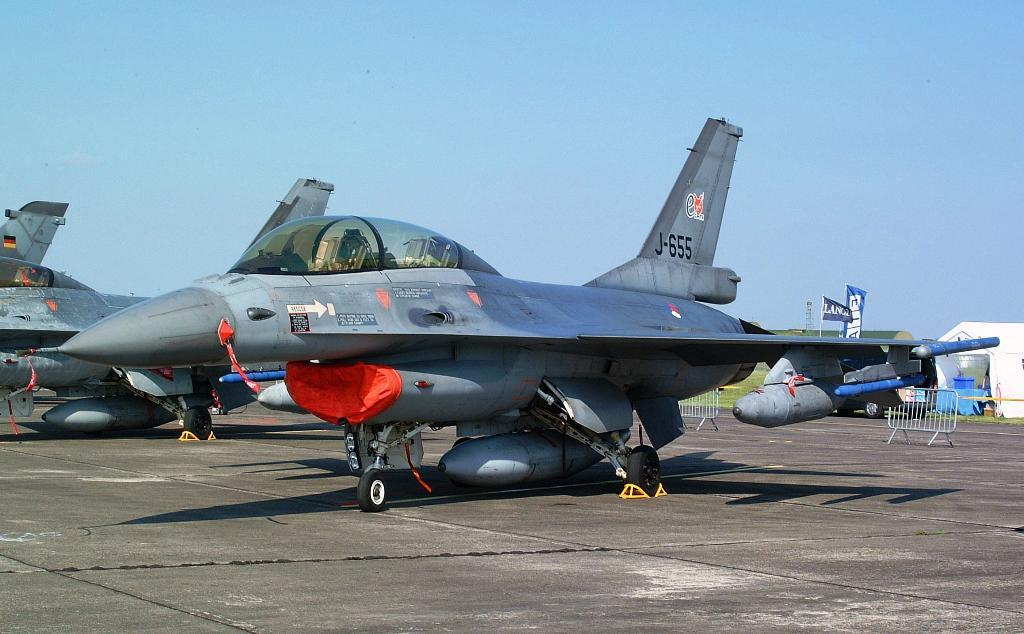What type of vehicles are on the road in the image? There are aircrafts on the road in the image. What structures can be seen in the image? There are stands in the image. What type of signage is present in the image? There are banners in the image. What is visible at the top of the image? The sky is visible at the top of the image. What type of skin condition can be seen on the aircrafts in the image? There is no skin condition present on the aircrafts in the image, as they are vehicles and not living organisms. 